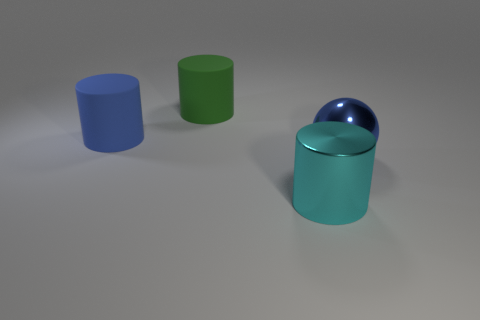Add 3 big metal objects. How many objects exist? 7 Subtract all balls. How many objects are left? 3 Add 2 green rubber objects. How many green rubber objects are left? 3 Add 3 small green cylinders. How many small green cylinders exist? 3 Subtract 0 red balls. How many objects are left? 4 Subtract all large blue shiny things. Subtract all tiny cyan matte things. How many objects are left? 3 